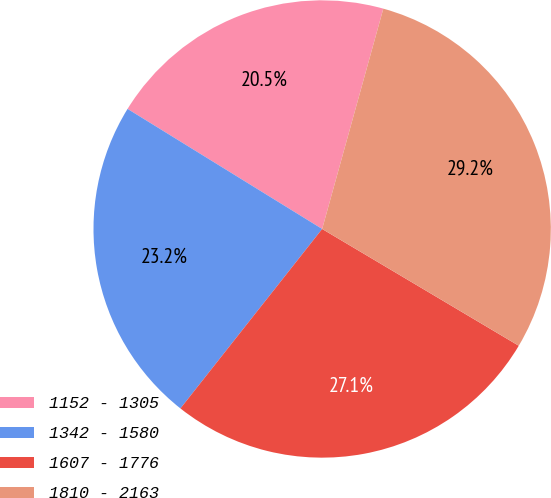<chart> <loc_0><loc_0><loc_500><loc_500><pie_chart><fcel>1152 - 1305<fcel>1342 - 1580<fcel>1607 - 1776<fcel>1810 - 2163<nl><fcel>20.51%<fcel>23.16%<fcel>27.11%<fcel>29.22%<nl></chart> 